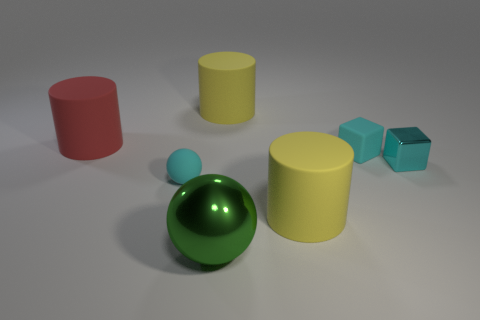How are the objects arranged in relation to the light source? The objects are arranged on a flat surface with the light source above them, casting soft shadows to the right of each object, indicating that the light is coming from the left side of the frame. 